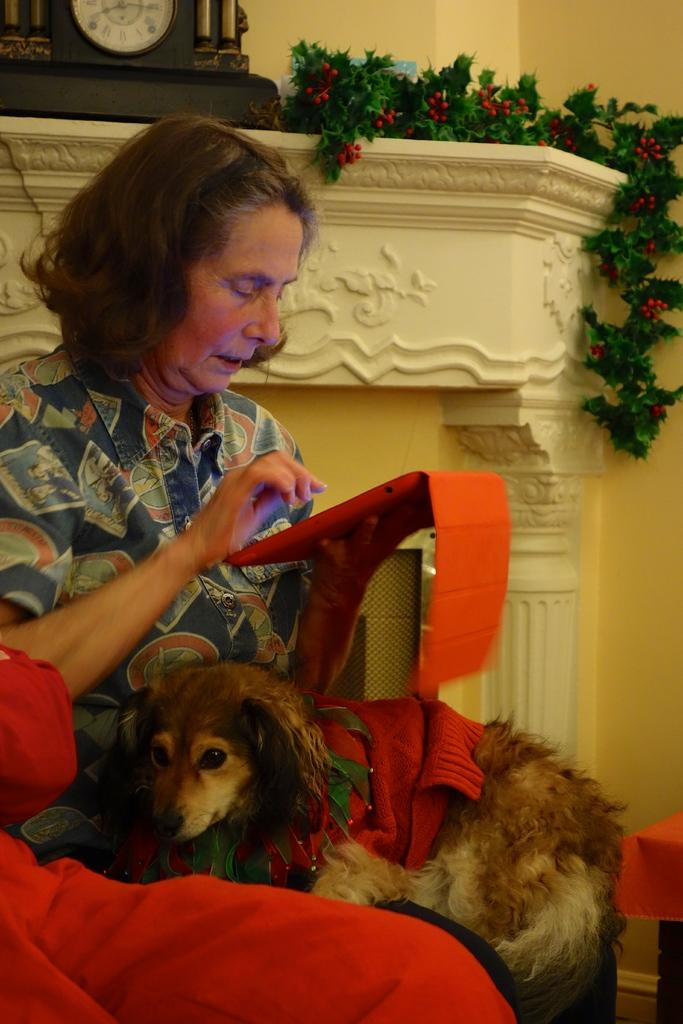Who is the main subject in the image? There is a lady in the image. What is the lady doing in the image? The lady is sitting in the image. What is on the lady's lap? There is a dog on the lady's lap. What object is the lady holding in the image? The lady is holding a tablet in the image. What can be seen in the background of the image? There is a clock and a plant in the background of the image. What type of hen is sitting on the lady's wrist in the image? There is no hen present in the image; it features a lady with a dog on her lap and a tablet in her hand. 